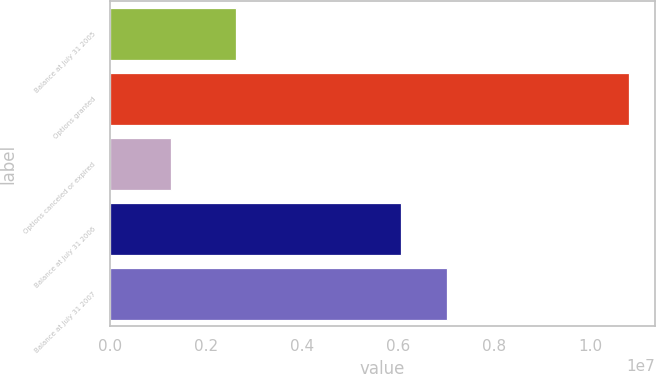Convert chart to OTSL. <chart><loc_0><loc_0><loc_500><loc_500><bar_chart><fcel>Balance at July 31 2005<fcel>Options granted<fcel>Options canceled or expired<fcel>Balance at July 31 2006<fcel>Balance at July 31 2007<nl><fcel>2.62638e+06<fcel>1.08161e+07<fcel>1.27059e+06<fcel>6.07209e+06<fcel>7.02664e+06<nl></chart> 